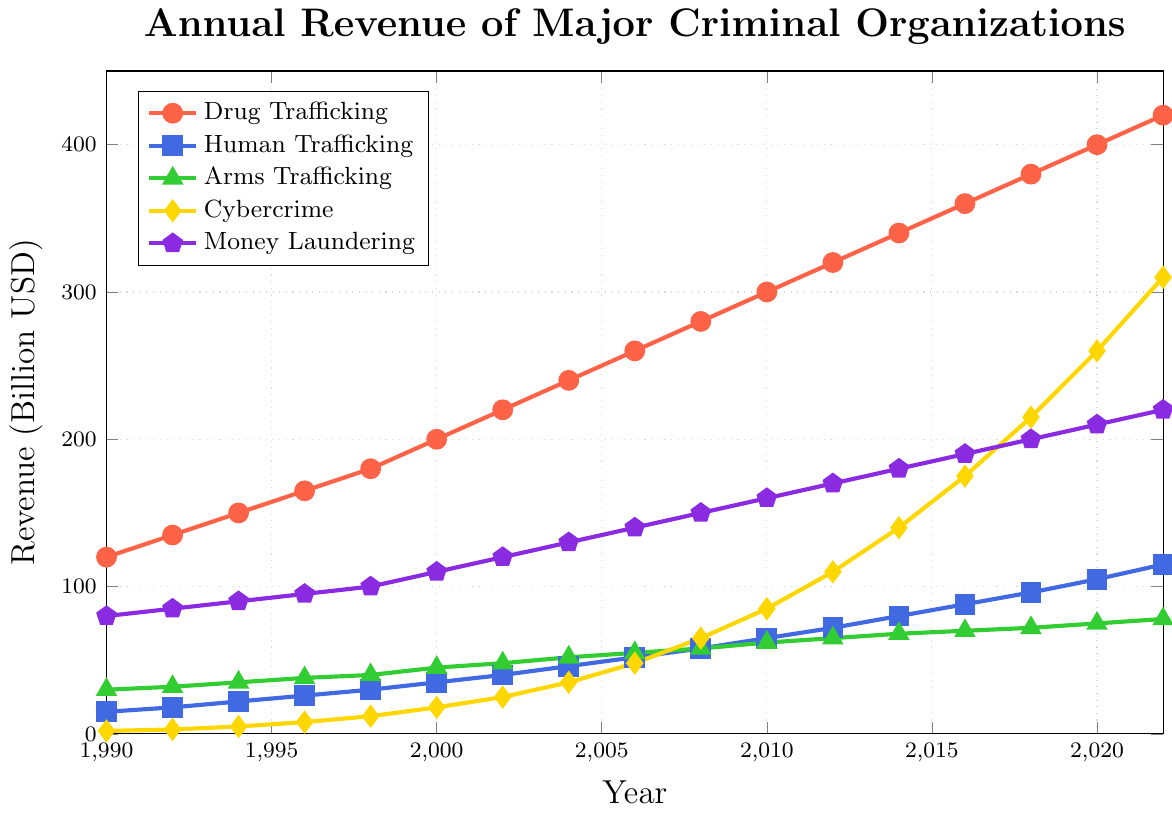What year did Cybercrime surpass Money Laundering in revenue? First, observe the two lines representing Cybercrime (yellow) and Money Laundering (purple). Notice that Cybercrime surpasses Money Laundering in the year 2018 where Cybercrime revenue is 215 billion USD and Money Laundering revenue is 200 billion USD.
Answer: 2018 Which illicit activity had the most revenue growth between 2000 and 2022? Calculate the revenue difference for each illicit activity between 2000 and 2022: Drug Trafficking (420-200=220), Human Trafficking (115-35=80), Arms Trafficking (78-45=33), Cybercrime (310-18=292), Money Laundering (220-110=110). Cybercrime has the highest growth of 292 billion USD.
Answer: Cybercrime What is the average annual revenue of Human Trafficking from 1990 to 2022? Sum the Human Trafficking values from each year: (15+18+22+26+30+35+40+46+52+58+65+72+80+88+96+105+115)=963. There are 17 data points. The average is 963/17.
Answer: 56.65 Which illicit activity's revenue increased the most between 2016 and 2020? Calculate the revenue difference for each activity between 2016 and 2020: Drug Trafficking (400-360=40), Human Trafficking (105-88=17), Arms Trafficking (75-70=5), Cybercrime (260-175=85), Money Laundering (210-190=20). Cybercrime has the highest increase of 85 billion USD.
Answer: Cybercrime What was the total combined revenue of all illicit activities in the year 2012? Sum the revenues of all activities for 2012: (320+72+65+110+170). The total is 737 billion USD.
Answer: 737 billion USD How does the rate of growth in revenue for Arms Trafficking compare to that of Drug Trafficking between 1990 and 1998? Calculate the revenue growth for each: Arms Trafficking (40-30=10 billion) and Drug Trafficking (180-120=60 billion). Then, calculate the number of years, which is 8. The growth rate is Arms Trafficking (10/8=1.25 billion per year) and Drug Trafficking (60/8=7.5 billion per year). Drug Trafficking's growth is higher.
Answer: Drug Trafficking's growth is higher 